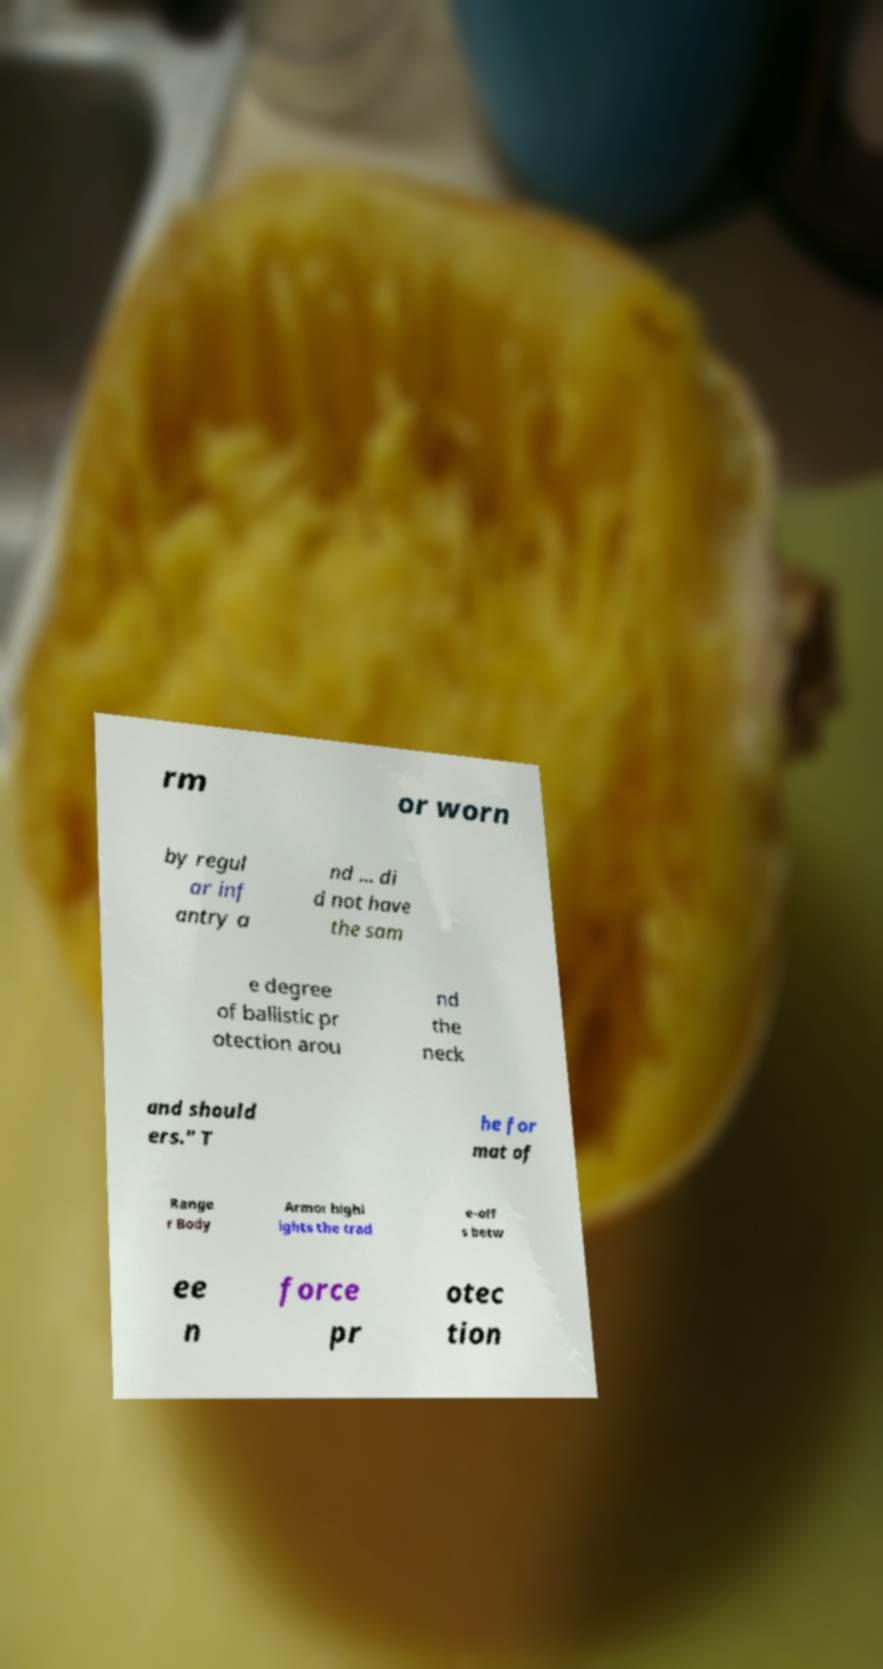Can you read and provide the text displayed in the image?This photo seems to have some interesting text. Can you extract and type it out for me? rm or worn by regul ar inf antry a nd ... di d not have the sam e degree of ballistic pr otection arou nd the neck and should ers." T he for mat of Range r Body Armor highl ights the trad e-off s betw ee n force pr otec tion 